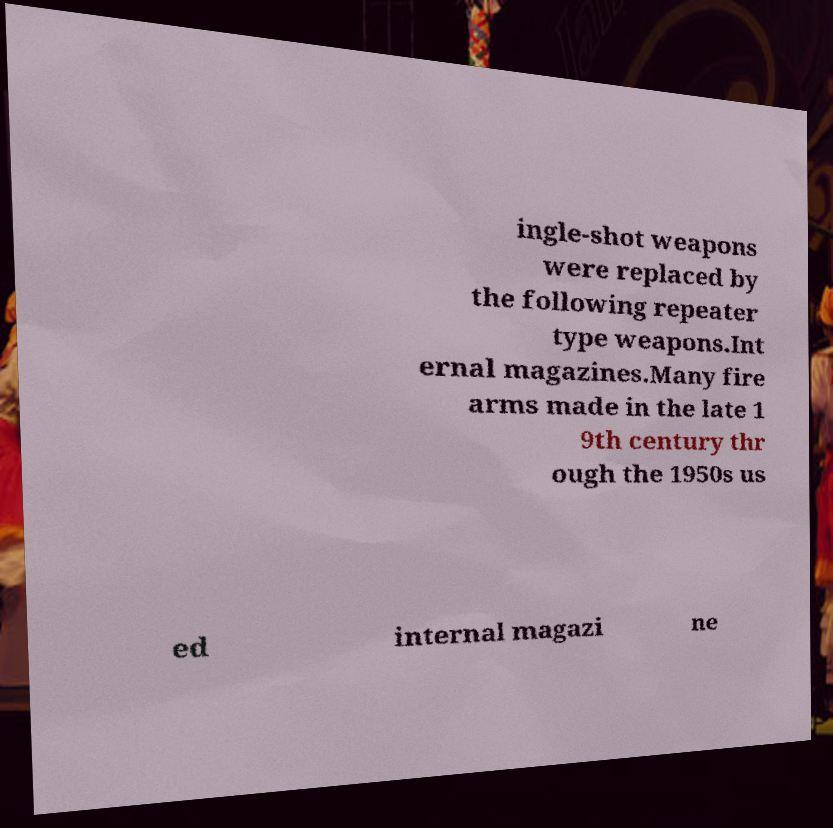I need the written content from this picture converted into text. Can you do that? ingle-shot weapons were replaced by the following repeater type weapons.Int ernal magazines.Many fire arms made in the late 1 9th century thr ough the 1950s us ed internal magazi ne 